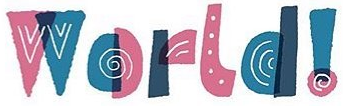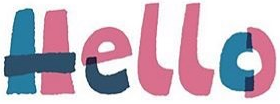What words are shown in these images in order, separated by a semicolon? World!; Hello 